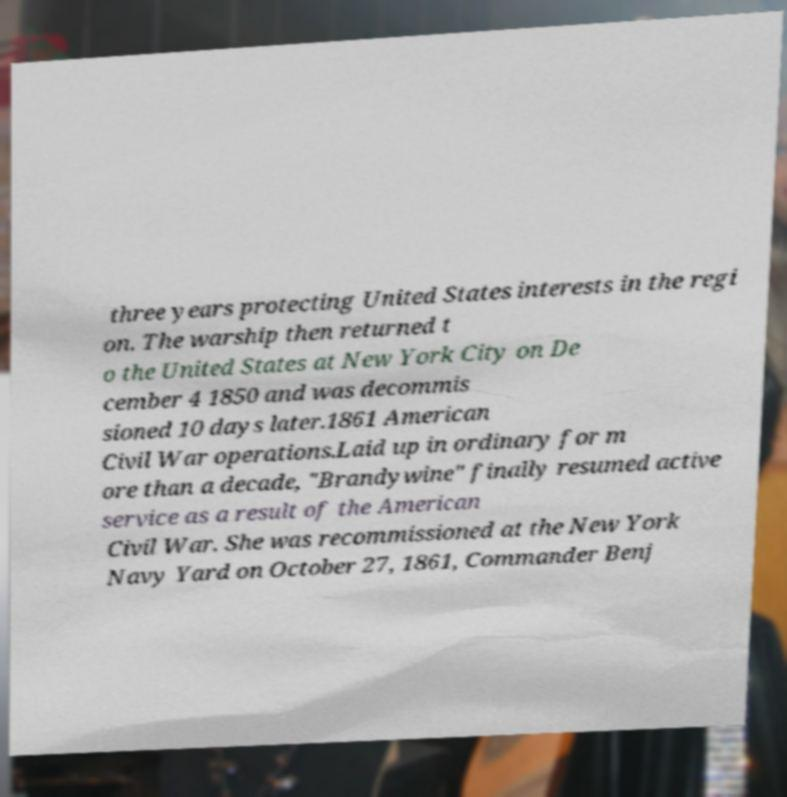Can you accurately transcribe the text from the provided image for me? three years protecting United States interests in the regi on. The warship then returned t o the United States at New York City on De cember 4 1850 and was decommis sioned 10 days later.1861 American Civil War operations.Laid up in ordinary for m ore than a decade, "Brandywine" finally resumed active service as a result of the American Civil War. She was recommissioned at the New York Navy Yard on October 27, 1861, Commander Benj 